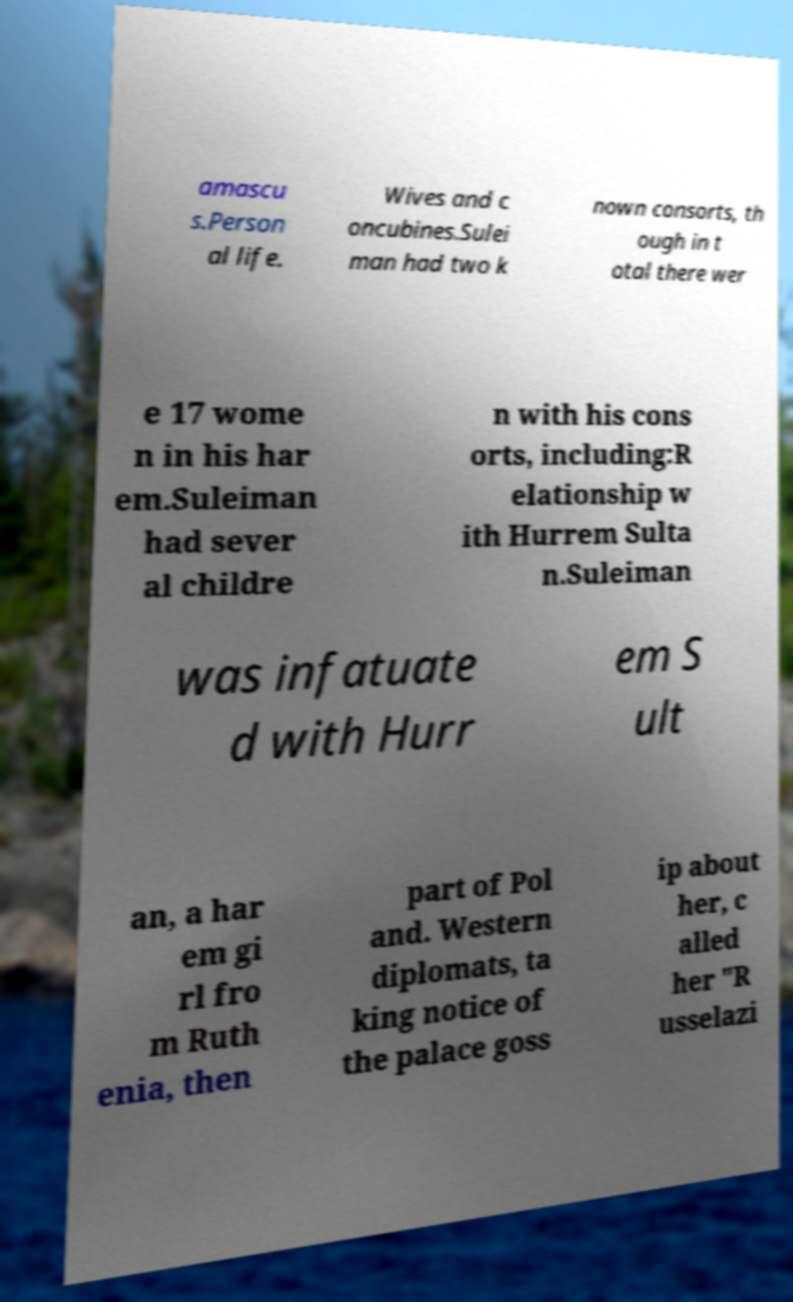There's text embedded in this image that I need extracted. Can you transcribe it verbatim? amascu s.Person al life. Wives and c oncubines.Sulei man had two k nown consorts, th ough in t otal there wer e 17 wome n in his har em.Suleiman had sever al childre n with his cons orts, including:R elationship w ith Hurrem Sulta n.Suleiman was infatuate d with Hurr em S ult an, a har em gi rl fro m Ruth enia, then part of Pol and. Western diplomats, ta king notice of the palace goss ip about her, c alled her "R usselazi 